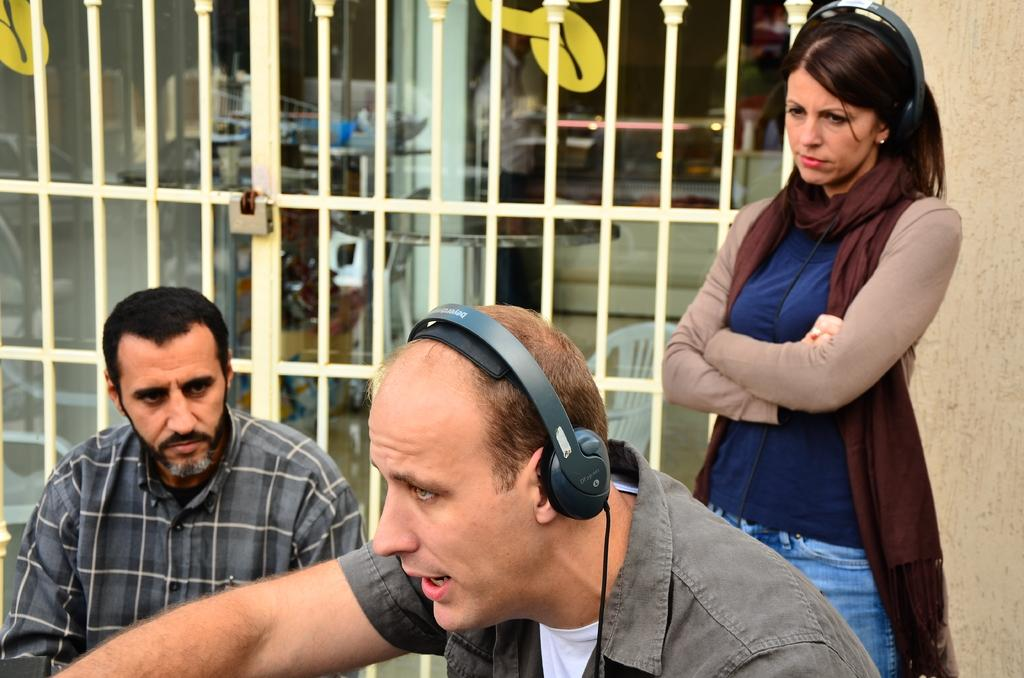How many people are in the image? There are people in the image, but the exact number is not specified. What are the people wearing that might indicate their role or activity? Two of the people are wearing headsets, which suggests they might be engaged in communication or a related activity. What can be seen in the background of the image? There is a gate and a fencing wall of a building in the image. What type of beetle can be seen crawling on the gate in the image? There is no beetle present in the image; it only features people, headsets, a gate, and a fencing wall of a building. 